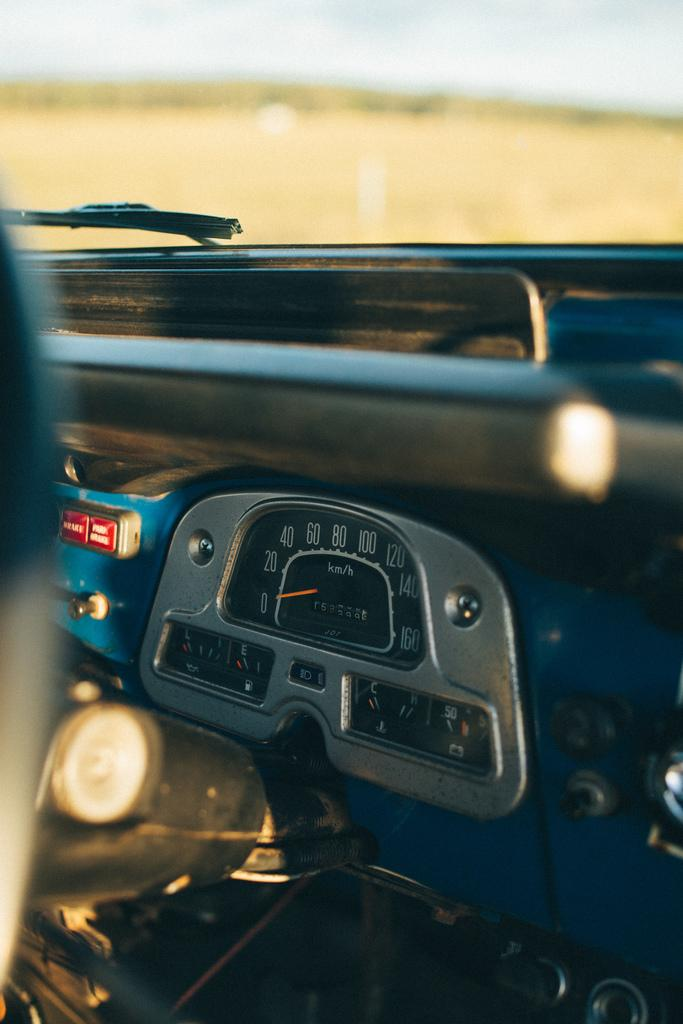What is the setting of the image? The image depicts the inside parts of a car. Can you describe any specific features or components visible in the image? Unfortunately, without more specific information about the image, it is difficult to describe any specific features or components. Is there a collar visible on the driver's seat in the image? There is no mention of a collar or a driver's seat in the provided fact, so it is not possible to determine if a collar is visible in the image. 